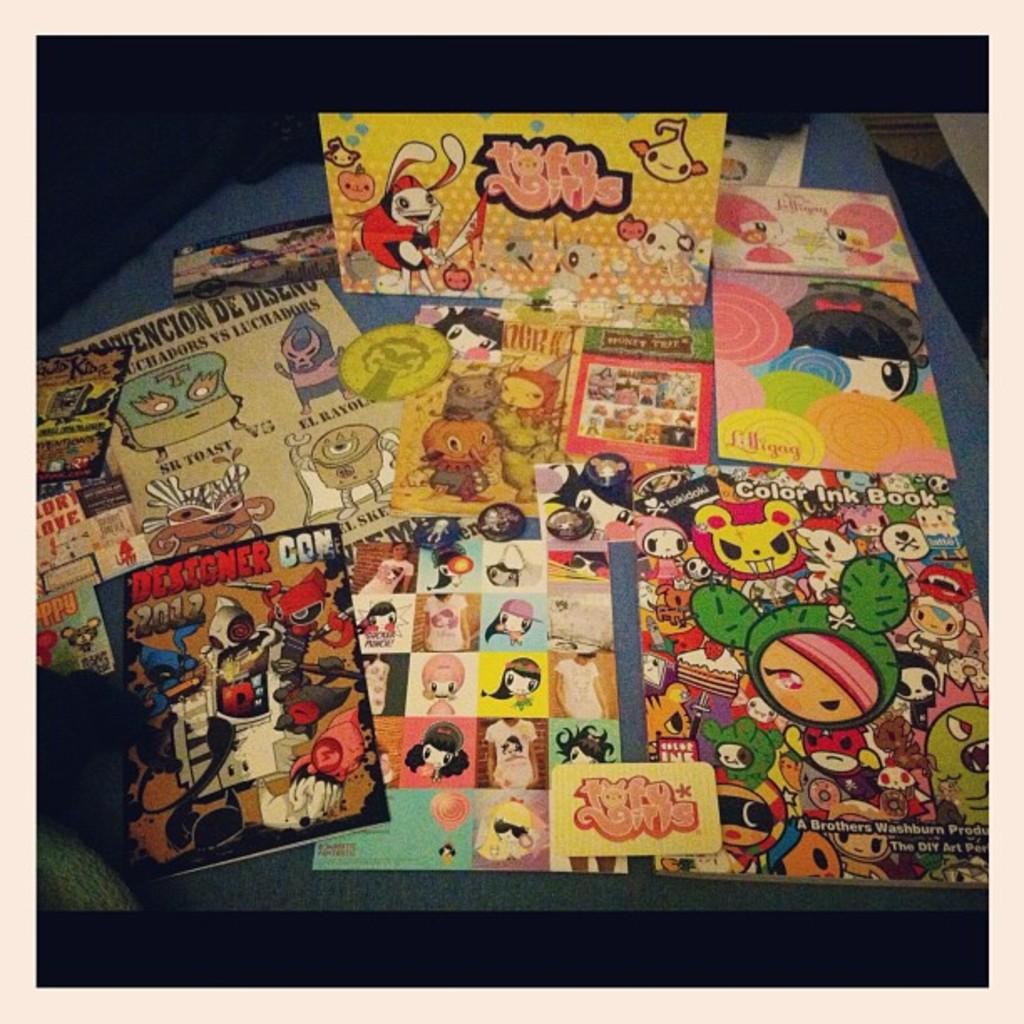What date was the comic on the lower left published?
Keep it short and to the point. 2012. 